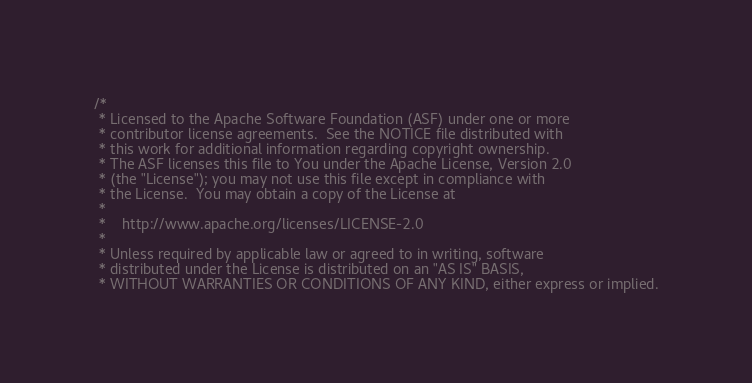<code> <loc_0><loc_0><loc_500><loc_500><_Scala_>/*
 * Licensed to the Apache Software Foundation (ASF) under one or more
 * contributor license agreements.  See the NOTICE file distributed with
 * this work for additional information regarding copyright ownership.
 * The ASF licenses this file to You under the Apache License, Version 2.0
 * (the "License"); you may not use this file except in compliance with
 * the License.  You may obtain a copy of the License at
 *
 *    http://www.apache.org/licenses/LICENSE-2.0
 *
 * Unless required by applicable law or agreed to in writing, software
 * distributed under the License is distributed on an "AS IS" BASIS,
 * WITHOUT WARRANTIES OR CONDITIONS OF ANY KIND, either express or implied.</code> 